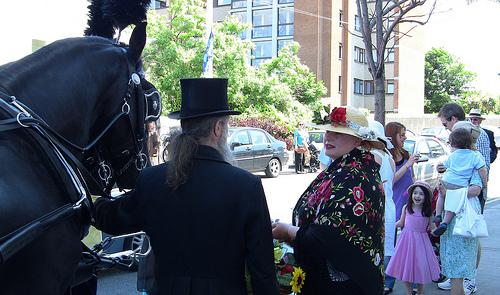Question: how many horses are in this picture?
Choices:
A. Two.
B. Three.
C. Four.
D. One.
Answer with the letter. Answer: D Question: who is wearing a pink dress?
Choices:
A. A woman.
B. A baby.
C. A little girl.
D. A doll.
Answer with the letter. Answer: C Question: what color is the little girl's dress?
Choices:
A. Purple.
B. Pink.
C. Red.
D. Blue.
Answer with the letter. Answer: B Question: what animal is in this picture?
Choices:
A. Cow.
B. Sheep.
C. Horse.
D. Dog.
Answer with the letter. Answer: C Question: where is the woman's hat?
Choices:
A. In her hand.
B. On the chair.
C. In the closet.
D. On her head.
Answer with the letter. Answer: D Question: what is on the man's head?
Choices:
A. Helmet.
B. Hoodie.
C. A hat.
D. Mask.
Answer with the letter. Answer: C 